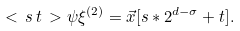<formula> <loc_0><loc_0><loc_500><loc_500>< \, s \, t \, > \psi \xi ^ { ( 2 ) } = { \vec { x } } [ s * 2 ^ { d - \sigma } + t ] .</formula> 